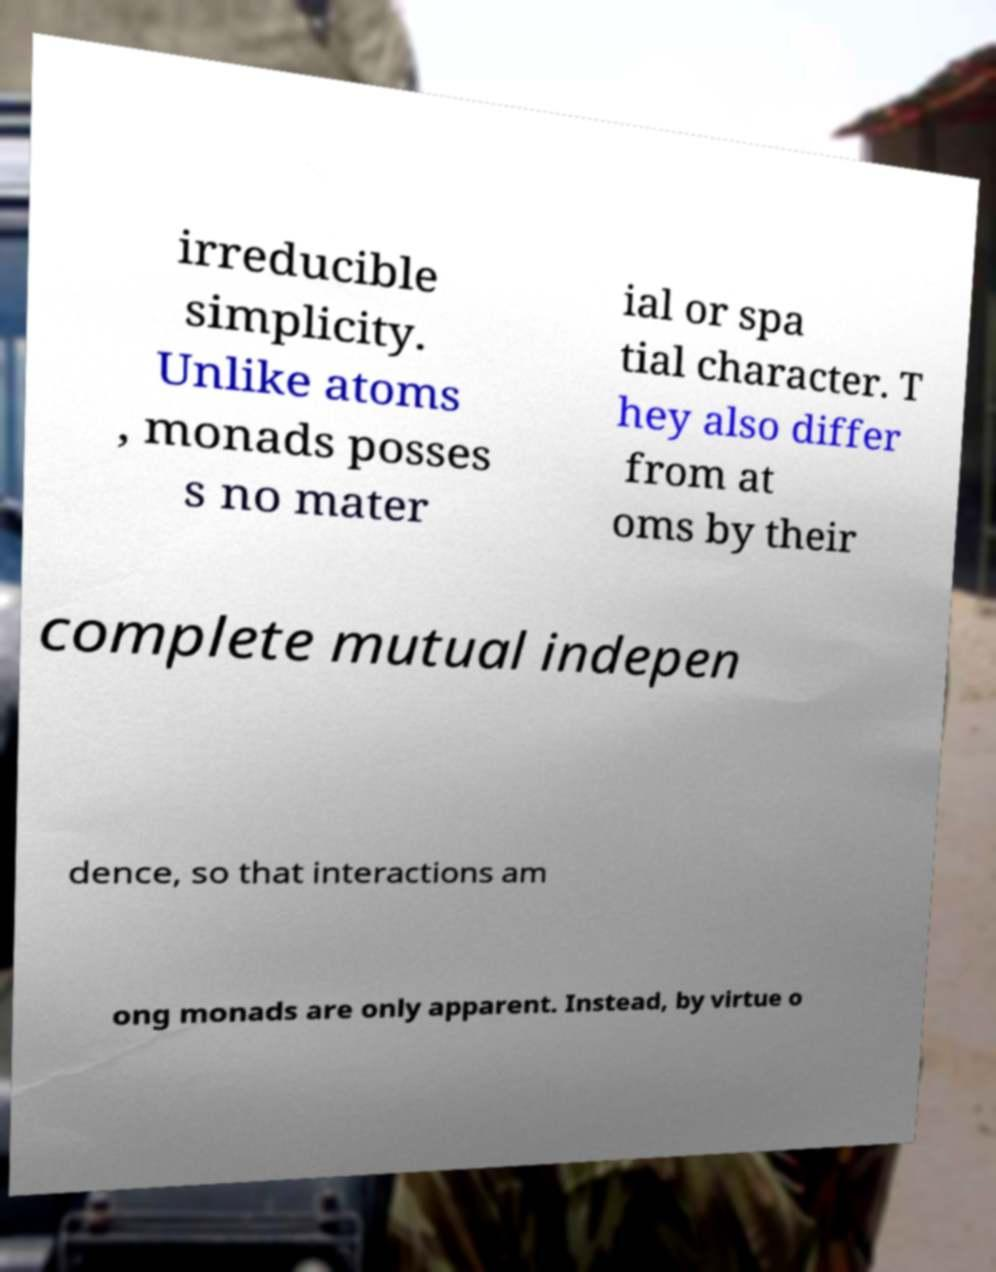I need the written content from this picture converted into text. Can you do that? irreducible simplicity. Unlike atoms , monads posses s no mater ial or spa tial character. T hey also differ from at oms by their complete mutual indepen dence, so that interactions am ong monads are only apparent. Instead, by virtue o 